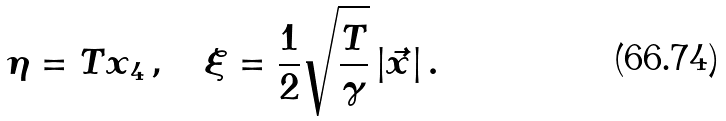Convert formula to latex. <formula><loc_0><loc_0><loc_500><loc_500>\eta = T x _ { 4 } \, , \quad \xi = \frac { 1 } { 2 } \sqrt { \frac { T } { \gamma } } \, | { \vec { x } } | \, .</formula> 